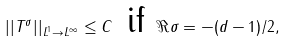<formula> <loc_0><loc_0><loc_500><loc_500>| | T ^ { \sigma } | | _ { L ^ { 1 } \to L ^ { \infty } } \leq C \, \text { if } \Re \sigma = - ( d - 1 ) / 2 ,</formula> 